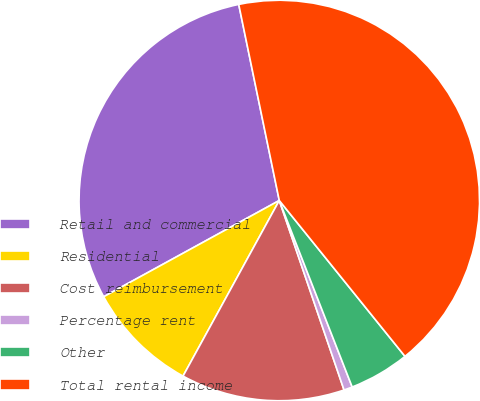<chart> <loc_0><loc_0><loc_500><loc_500><pie_chart><fcel>Retail and commercial<fcel>Residential<fcel>Cost reimbursement<fcel>Percentage rent<fcel>Other<fcel>Total rental income<nl><fcel>29.73%<fcel>9.04%<fcel>13.22%<fcel>0.69%<fcel>4.87%<fcel>42.44%<nl></chart> 